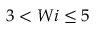<formula> <loc_0><loc_0><loc_500><loc_500>3 < W i \leq 5</formula> 